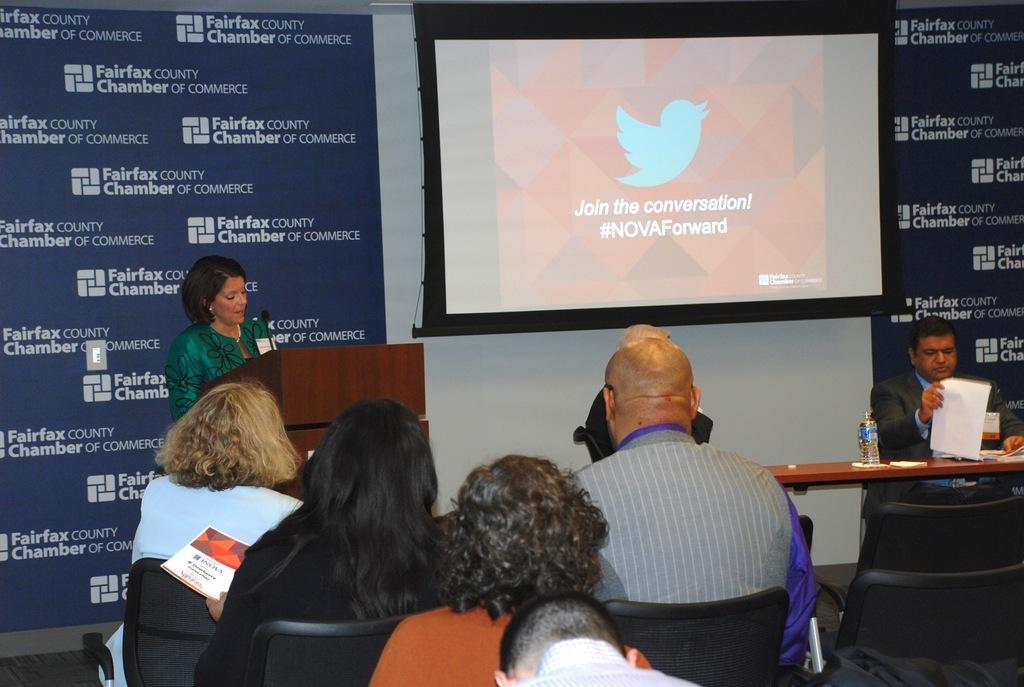Please provide a concise description of this image. There are persons in different color dresses sitting on chairs. In the background, there is a woman in green color dress speaking in front of a mic which is on the wooden stand near a hoarding, there is a screen and there is a person sitting on a chair and holding a document in front of table on which, there is a bottle and other objects near a hoarding and white wall. 